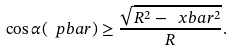<formula> <loc_0><loc_0><loc_500><loc_500>\cos \alpha ( \ p b a r ) \geq \frac { \sqrt { R ^ { 2 } - \ x b a r ^ { 2 } } } { R } .</formula> 